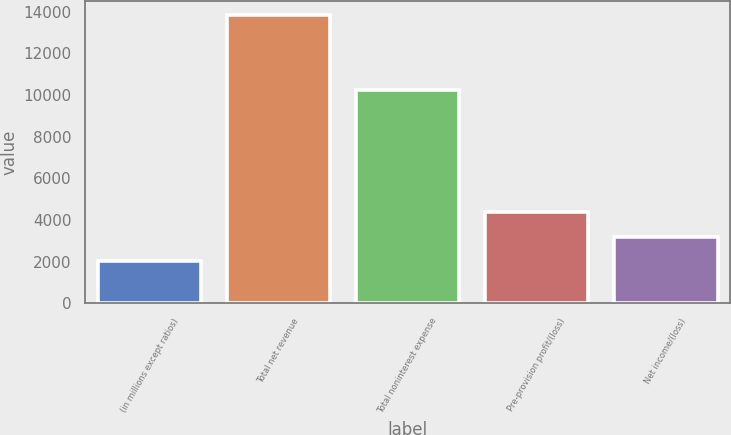Convert chart to OTSL. <chart><loc_0><loc_0><loc_500><loc_500><bar_chart><fcel>(in millions except ratios)<fcel>Total net revenue<fcel>Total noninterest expense<fcel>Pre-provision profit/(loss)<fcel>Net income/(loss)<nl><fcel>2017<fcel>13835<fcel>10218<fcel>4380.6<fcel>3198.8<nl></chart> 